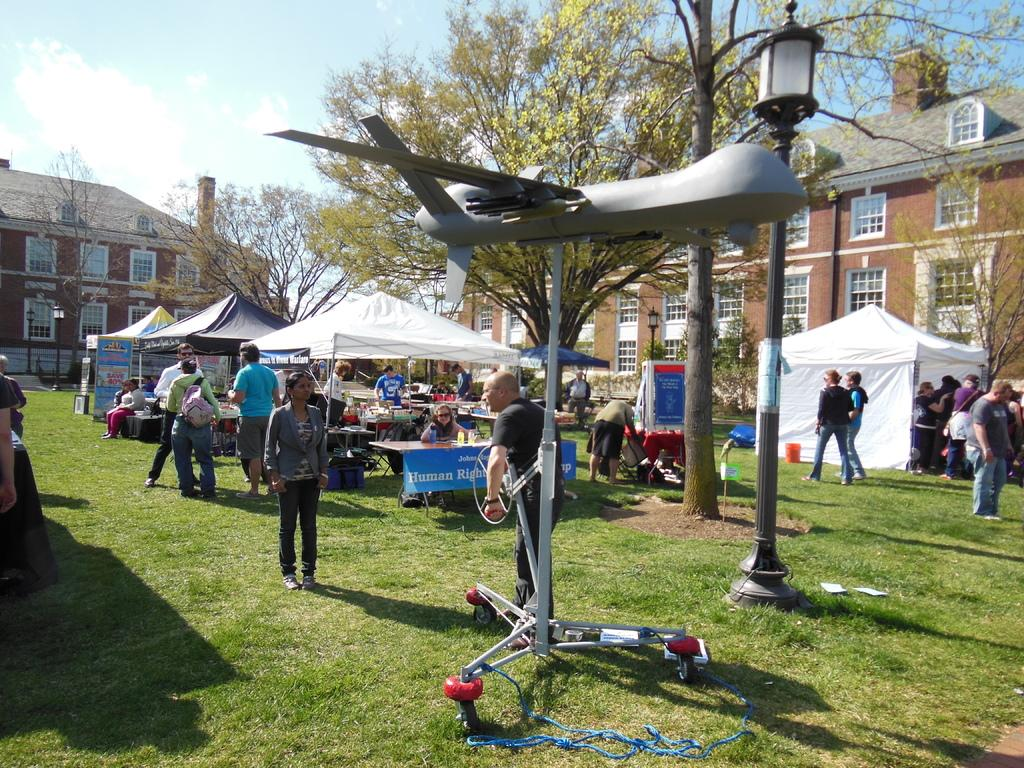How many people can be seen in the image? There are people in the image, but the exact number is not specified. What type of temporary shelters are visible in the image? There are tents in the image. What kind of signage is present in the image? Banners are present in the image. What are the poles used for in the image? Poles are visible in the image, but their purpose is not specified. What type of furniture is in the image? Tables are in the image. What type of natural vegetation is present in the image? Trees are present in the image. What objects can be seen on the ground in the image? There are objects on the ground in the image, but their specific nature is not mentioned. What type of structures are visible in the background of the image? There are buildings in the background of the image. What is visible in the sky in the image? The sky is visible in the background of the image, and clouds are present in it. What type of wool is being used to create the scarecrow in the image? There is no scarecrow present in the image, so the type of wool being used cannot be determined. What is the edge of the image used for? The edge of the image is not a physical object or element in the scene, so it does not have a specific function or purpose within the image. 